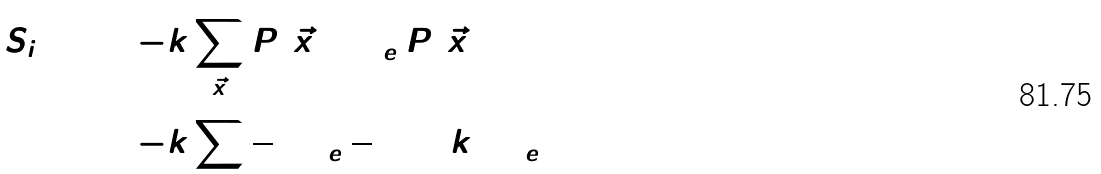<formula> <loc_0><loc_0><loc_500><loc_500>S _ { i } ( 3 ) & = - k \sum _ { \vec { x } } P ( \vec { x } ) \log _ { e } P ( \vec { x } ) \\ & = - k \sum \frac { 1 } { 8 } \log _ { e } \frac { 1 } { 8 } = 3 \, k \log _ { e } 2</formula> 